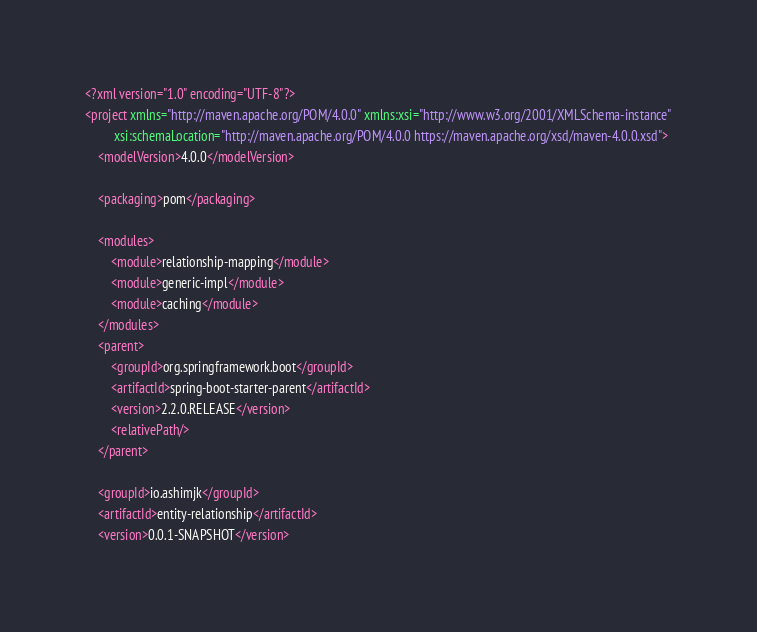<code> <loc_0><loc_0><loc_500><loc_500><_XML_><?xml version="1.0" encoding="UTF-8"?>
<project xmlns="http://maven.apache.org/POM/4.0.0" xmlns:xsi="http://www.w3.org/2001/XMLSchema-instance"
         xsi:schemaLocation="http://maven.apache.org/POM/4.0.0 https://maven.apache.org/xsd/maven-4.0.0.xsd">
    <modelVersion>4.0.0</modelVersion>

    <packaging>pom</packaging>

    <modules>
        <module>relationship-mapping</module>
        <module>generic-impl</module>
        <module>caching</module>
    </modules>
    <parent>
        <groupId>org.springframework.boot</groupId>
        <artifactId>spring-boot-starter-parent</artifactId>
        <version>2.2.0.RELEASE</version>
        <relativePath/>
    </parent>

    <groupId>io.ashimjk</groupId>
    <artifactId>entity-relationship</artifactId>
    <version>0.0.1-SNAPSHOT</version></code> 